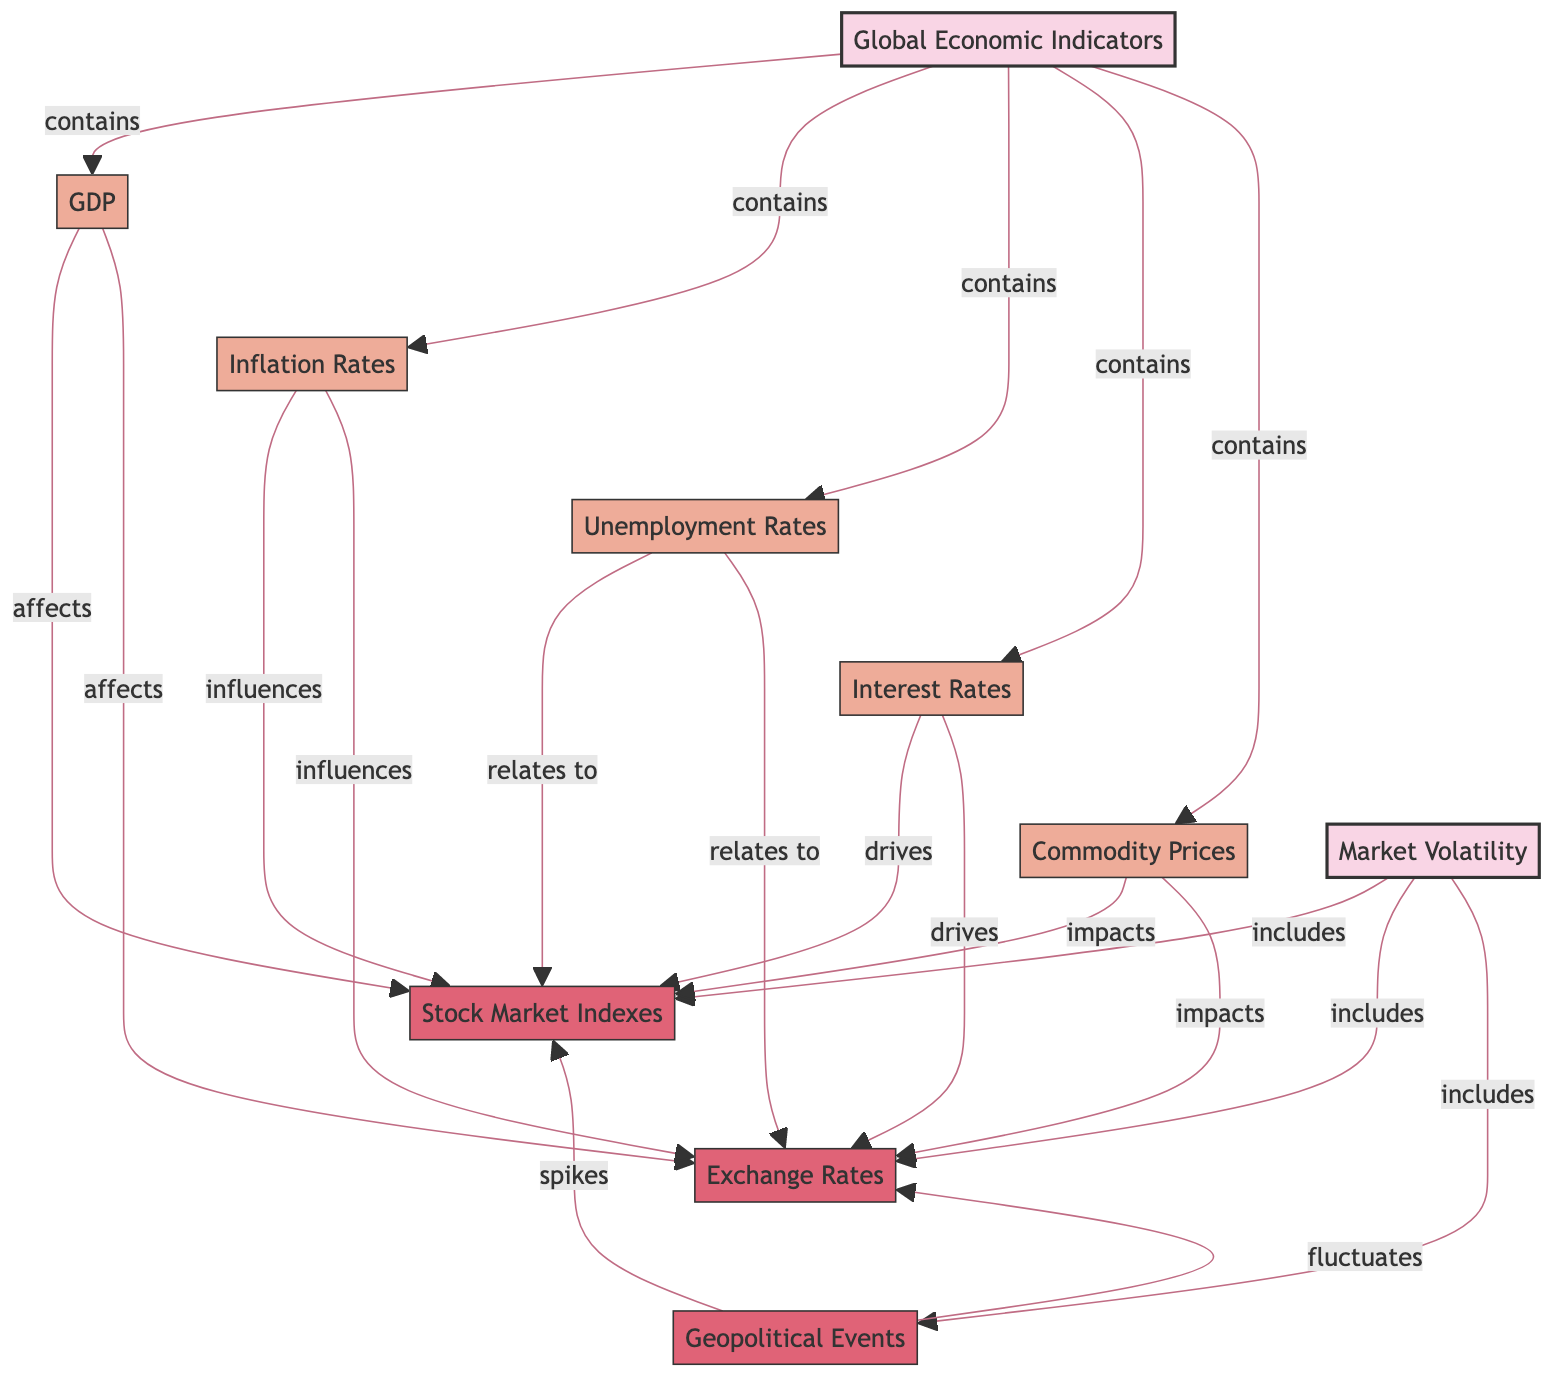What is the main category represented in the diagram? The primary categories highlighted in the diagram are "Global Economic Indicators" and "Market Volatility." These categories are the broadest classifications under which the specific indicators and volatility types fall.
Answer: Global Economic Indicators How many indicators are listed under Global Economic Indicators? There are five indicators listed, consisting of GDP, Inflation Rates, Unemployment Rates, Interest Rates, and Commodity Prices. This can be verified by counting the nodes that connect to the Global Economic Indicators node.
Answer: 5 Which economic indicator affects Stock Market Indexes? The diagram specifies that GDP, Inflation Rates, Unemployment Rates, Interest Rates, and Commodity Prices all have a direct effect on Stock Market Indexes. This is shown by the arrows connecting each of these indicators to Stock Market Indexes.
Answer: GDP, Inflation Rates, Unemployment Rates, Interest Rates, Commodity Prices What type of market volatility is influenced by Unemployment Rates? Unemployment Rates have a connection marked "relates to" leading to Stock Market Indexes and Exchange Rates, indicating that they influence both types of volatility.
Answer: Stock Market Indexes, Exchange Rates Which relationship indicates that Geopolitical Events spike market volatility? The diagram shows that "Geopolitical Events" are connected to "Stock Market Indexes" with the label "spikes," meaning that Geopolitical Events lead to significant increases in volatility.
Answer: spikes How many nodes are involved in the connections between Global Economic Indicators and Market Volatility? Counting all nodes shows there are ten total nodes, including both categories and specified indicators or types of volatility. Hence, the overall connections can be understood as composed of multiple nodes under categories.
Answer: 10 What is the relationship between Inflation Rates and Exchange Rates? The diagram reveals Inflation Rates "influence" Exchange Rates; thus, there is a direct connection that outlines the impact of inflation on currency values in the market.
Answer: influences Which indicators drive market volatility? Interest Rates are explicitly connected to Stock Market Indexes and Exchange Rates, indicated by the label "drives." Thus, they play a crucial role in driving market volatility.
Answer: Interest Rates 